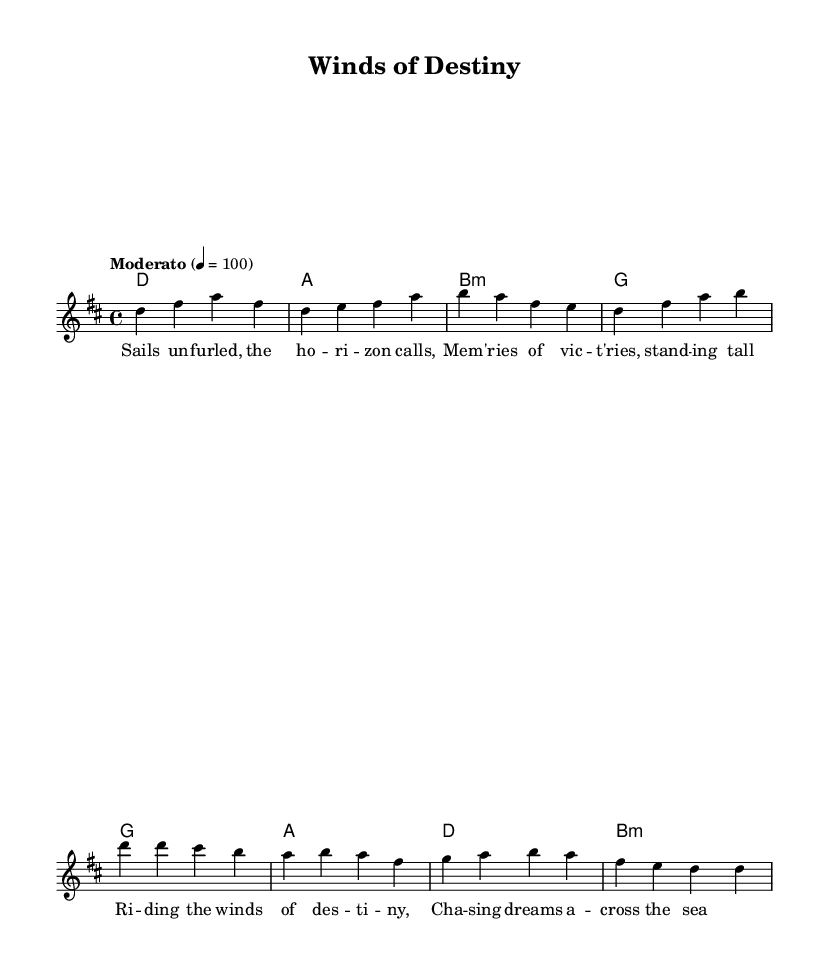What is the key signature of this music? The key signature indicates the key of D major, which has two sharps: F# and C#. This can be identified by looking at the beginning of the staff where the sharps are placed.
Answer: D major What is the time signature of the piece? The time signature is 4/4, indicating four beats per measure. This can be found near the beginning of the score, shown as a fraction.
Answer: 4/4 What is the tempo marking for this piece? The tempo marking is "Moderato" 4 = 100, meaning it should be played at a moderate speed of 100 beats per minute. This is indicated at the beginning of the score.
Answer: Moderato 4 = 100 How many measures are in the verse section? The verse contains two measures based on the notation of the melody line, which clearly groups the notes into two individual measures.
Answer: 2 What type of chords are primarily used in the verse? The verse primarily uses major and minor chords, specifically D major, A major, B minor, and G major, all of which are displayed in the harmony section of the score.
Answer: Major and minor chords What is the lyrical theme of the song? The lyrics depict themes of sailing and memories, referring to journeys and adventures across the sea, which can be inferred from the text written under the melody.
Answer: Sailing and memories 